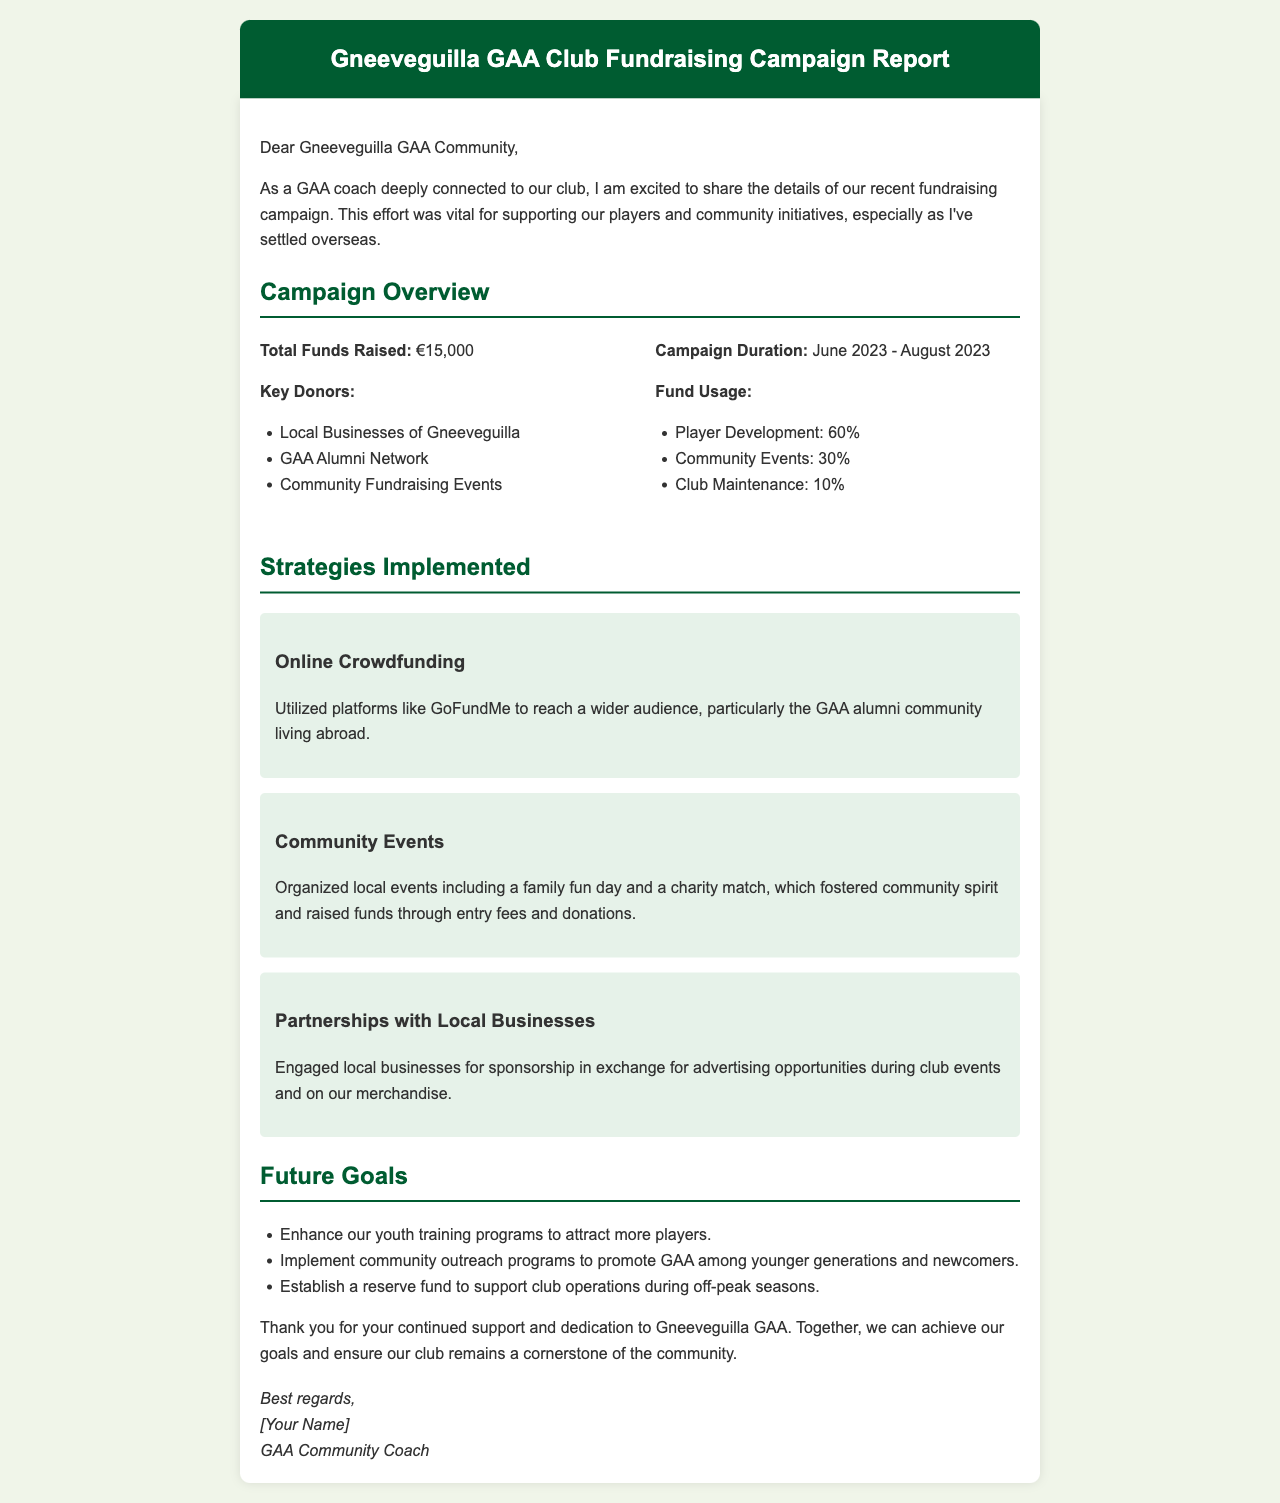what is the total funds raised? The total funds raised is explicitly mentioned in the report under the Campaign Overview section.
Answer: €15,000 what was the duration of the campaign? The campaign duration is specified in the document in the Campaign Overview section.
Answer: June 2023 - August 2023 who are the key donors mentioned? The report lists key donors in the Campaign Overview section.
Answer: Local Businesses of Gneeveguilla, GAA Alumni Network, Community Fundraising Events how much of the funds were allocated to Player Development? The allocation for Player Development is detailed in the Fund Usage section of the document.
Answer: 60% which strategy involved GoFundMe? The strategy that utilized GoFundMe is mentioned in the Strategies Implemented section.
Answer: Online Crowdfunding what community events helped in fundraising? The report describes organized events that contributed to fundraising in the Strategies Implemented section.
Answer: Family fun day, charity match what is one of the future goals for the club? Future goals for the club are mentioned at the end of the document.
Answer: Enhance our youth training programs what type of community programs does the club want to implement? The document mentions community outreach programs in the Future Goals section.
Answer: Community outreach programs who signed off the report? The signature part of the document indicates who signed it.
Answer: [Your Name] 